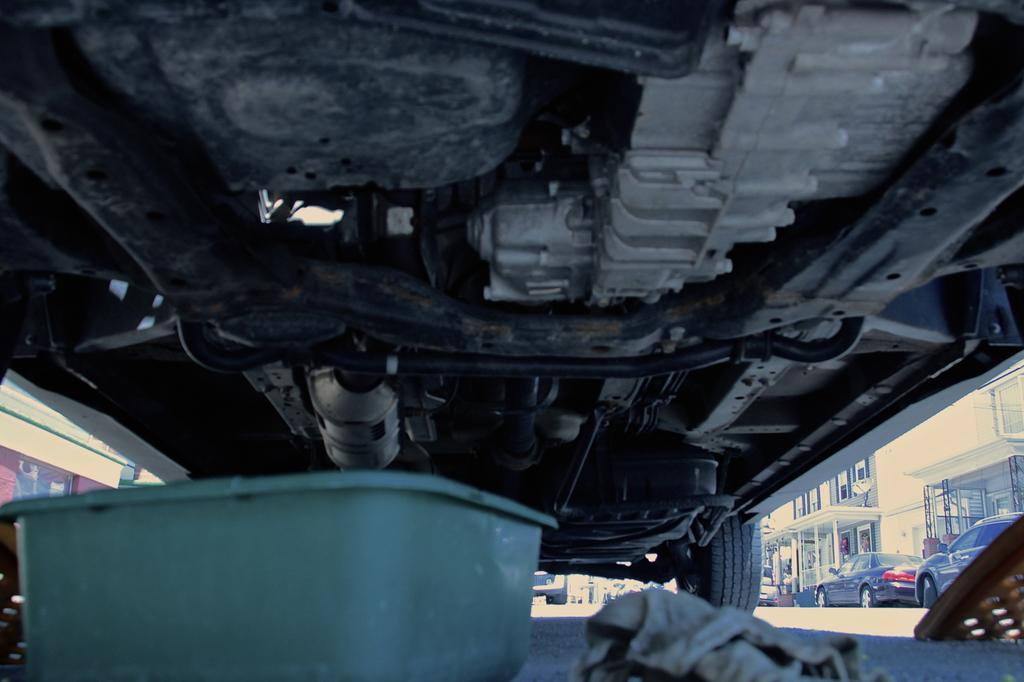In one or two sentences, can you explain what this image depicts? In this image we can see the bottom view of a car. We can also see a green color tub and a cloth on the road. On the right we can see the buildings and also the cars. On the left we can also see a building. 